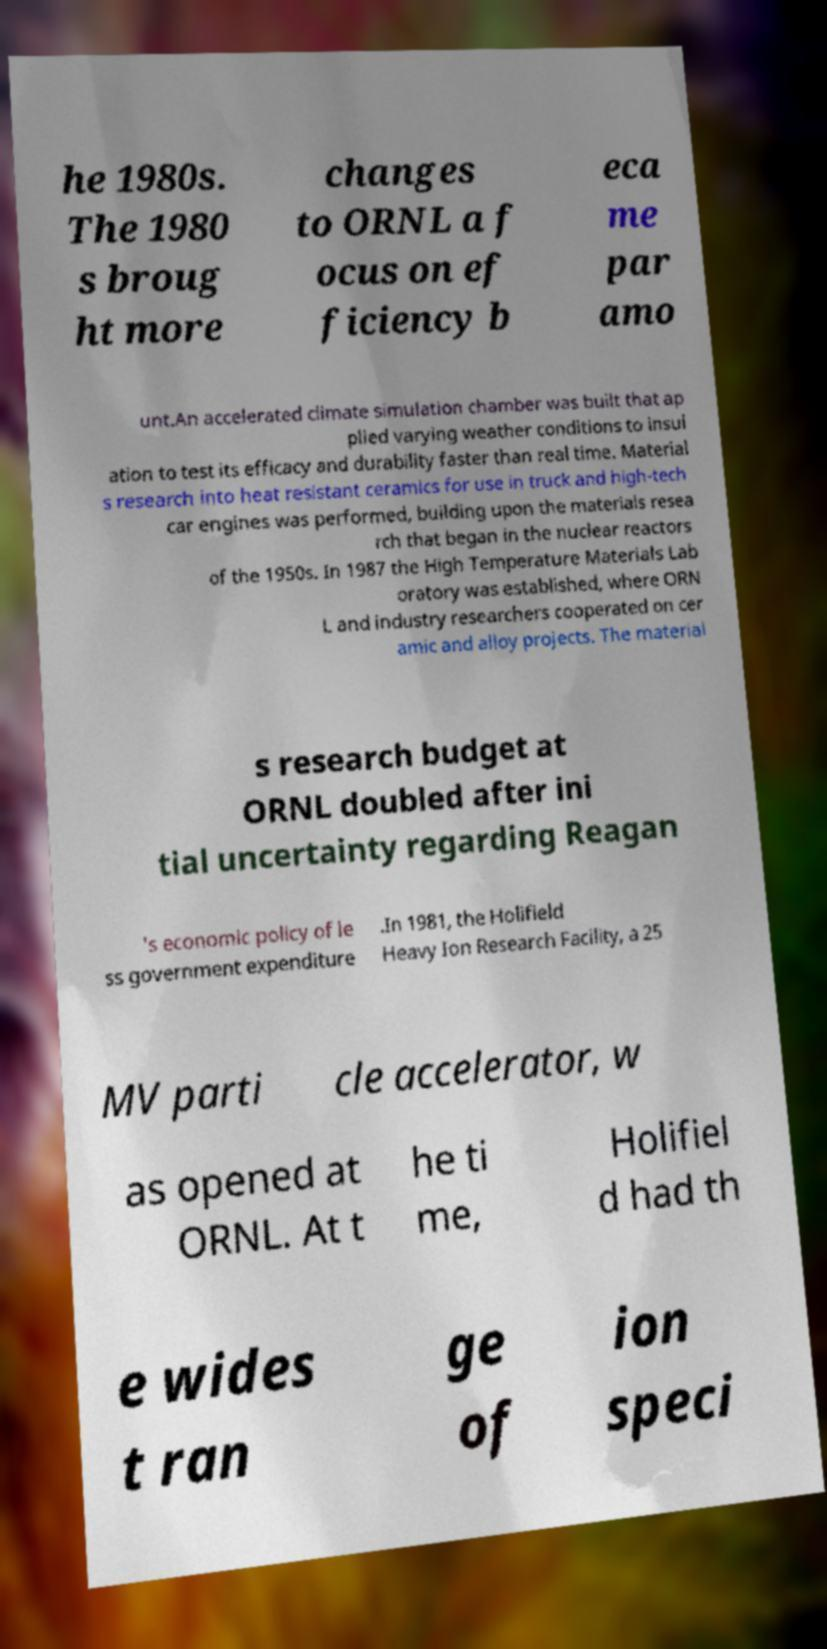I need the written content from this picture converted into text. Can you do that? he 1980s. The 1980 s broug ht more changes to ORNL a f ocus on ef ficiency b eca me par amo unt.An accelerated climate simulation chamber was built that ap plied varying weather conditions to insul ation to test its efficacy and durability faster than real time. Material s research into heat resistant ceramics for use in truck and high-tech car engines was performed, building upon the materials resea rch that began in the nuclear reactors of the 1950s. In 1987 the High Temperature Materials Lab oratory was established, where ORN L and industry researchers cooperated on cer amic and alloy projects. The material s research budget at ORNL doubled after ini tial uncertainty regarding Reagan 's economic policy of le ss government expenditure .In 1981, the Holifield Heavy Ion Research Facility, a 25 MV parti cle accelerator, w as opened at ORNL. At t he ti me, Holifiel d had th e wides t ran ge of ion speci 